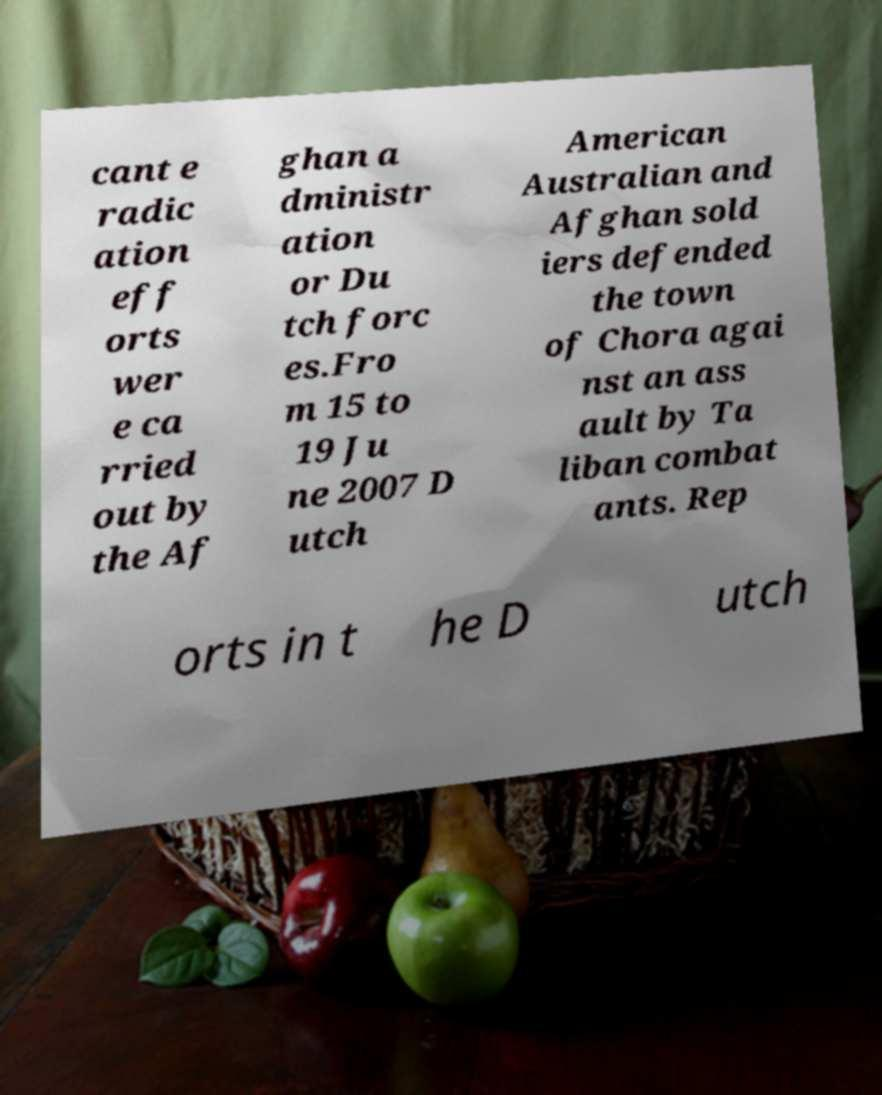Please read and relay the text visible in this image. What does it say? cant e radic ation eff orts wer e ca rried out by the Af ghan a dministr ation or Du tch forc es.Fro m 15 to 19 Ju ne 2007 D utch American Australian and Afghan sold iers defended the town of Chora agai nst an ass ault by Ta liban combat ants. Rep orts in t he D utch 